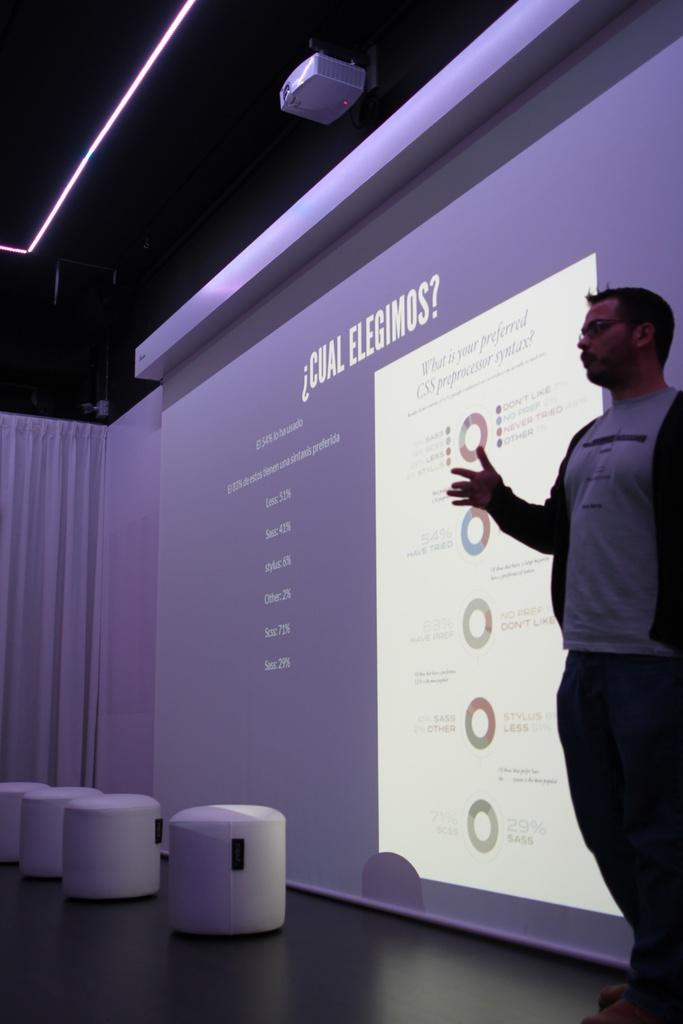What is the man in the image doing? The man is standing on stage in the image. What is located beside the man on stage? There is a screen beside the man on stage. How many tables can be seen in the background of the image? There are four tables in the background of the image. What is present in the background of the image that might be used for hiding or decoration? There is a curtain in the background of the image. What device is visible at the top of the image that might be used for displaying visuals? There is a projector visible at the top of the image. Can you see any goldfish swimming in the background of the image? There are no goldfish present in the image. Is the man wearing a mask while standing on stage in the image? There is no indication that the man is wearing a mask in the image. 